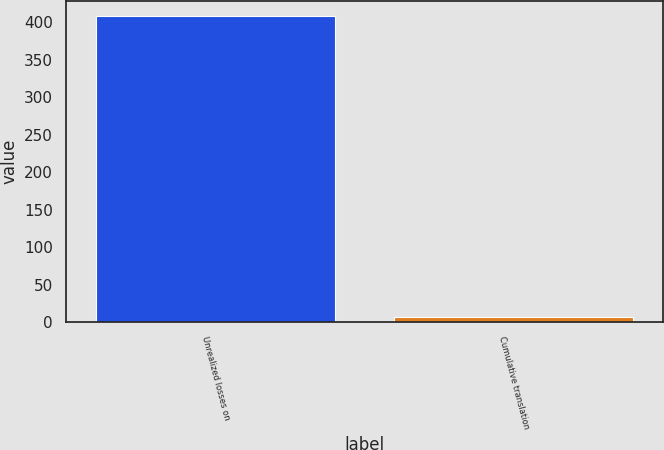<chart> <loc_0><loc_0><loc_500><loc_500><bar_chart><fcel>Unrealized losses on<fcel>Cumulative translation<nl><fcel>408<fcel>7<nl></chart> 